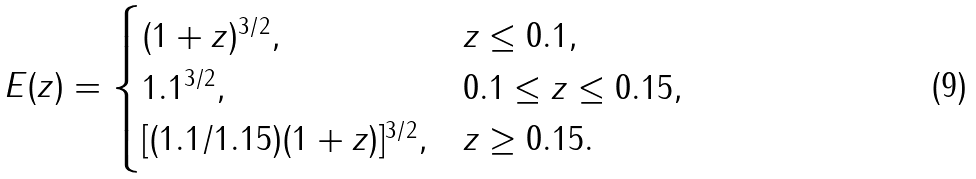Convert formula to latex. <formula><loc_0><loc_0><loc_500><loc_500>E ( z ) = \begin{cases} ( 1 + z ) ^ { 3 / 2 } , & z \leq 0 . 1 , \\ 1 . 1 ^ { 3 / 2 } , & 0 . 1 \leq z \leq 0 . 1 5 , \\ [ ( 1 . 1 / 1 . 1 5 ) ( 1 + z ) ] ^ { 3 / 2 } , & z \geq 0 . 1 5 . \end{cases}</formula> 